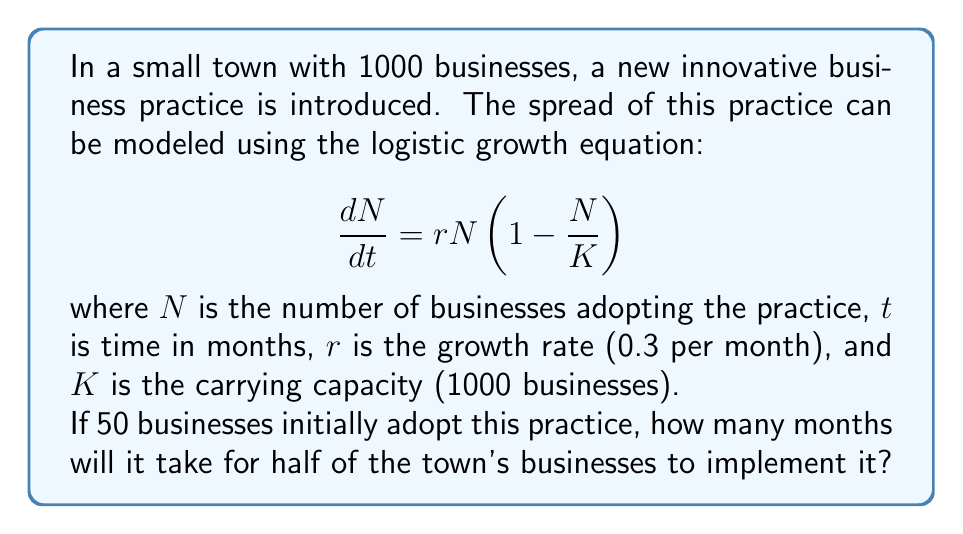Can you solve this math problem? To solve this problem, we need to use the analytical solution of the logistic growth equation:

$$N(t) = \frac{K}{1 + (\frac{K}{N_0} - 1)e^{-rt}}$$

Where $N_0$ is the initial number of businesses adopting the practice.

Given:
- $K = 1000$ (carrying capacity)
- $r = 0.3$ (growth rate per month)
- $N_0 = 50$ (initial number of adopters)
- We want to find $t$ when $N(t) = 500$ (half of the businesses)

Step 1: Substitute the known values into the equation:

$$500 = \frac{1000}{1 + (\frac{1000}{50} - 1)e^{-0.3t}}$$

Step 2: Simplify:

$$500 = \frac{1000}{1 + 19e^{-0.3t}}$$

Step 3: Multiply both sides by $(1 + 19e^{-0.3t})$:

$$500(1 + 19e^{-0.3t}) = 1000$$

Step 4: Expand:

$$500 + 9500e^{-0.3t} = 1000$$

Step 5: Subtract 500 from both sides:

$$9500e^{-0.3t} = 500$$

Step 6: Divide both sides by 9500:

$$e^{-0.3t} = \frac{1}{19}$$

Step 7: Take the natural log of both sides:

$$-0.3t = \ln(\frac{1}{19})$$

Step 8: Solve for $t$:

$$t = -\frac{\ln(\frac{1}{19})}{0.3} = \frac{\ln(19)}{0.3} \approx 9.97$$

Therefore, it will take approximately 9.97 months for half of the town's businesses to adopt the new practice.
Answer: 9.97 months 